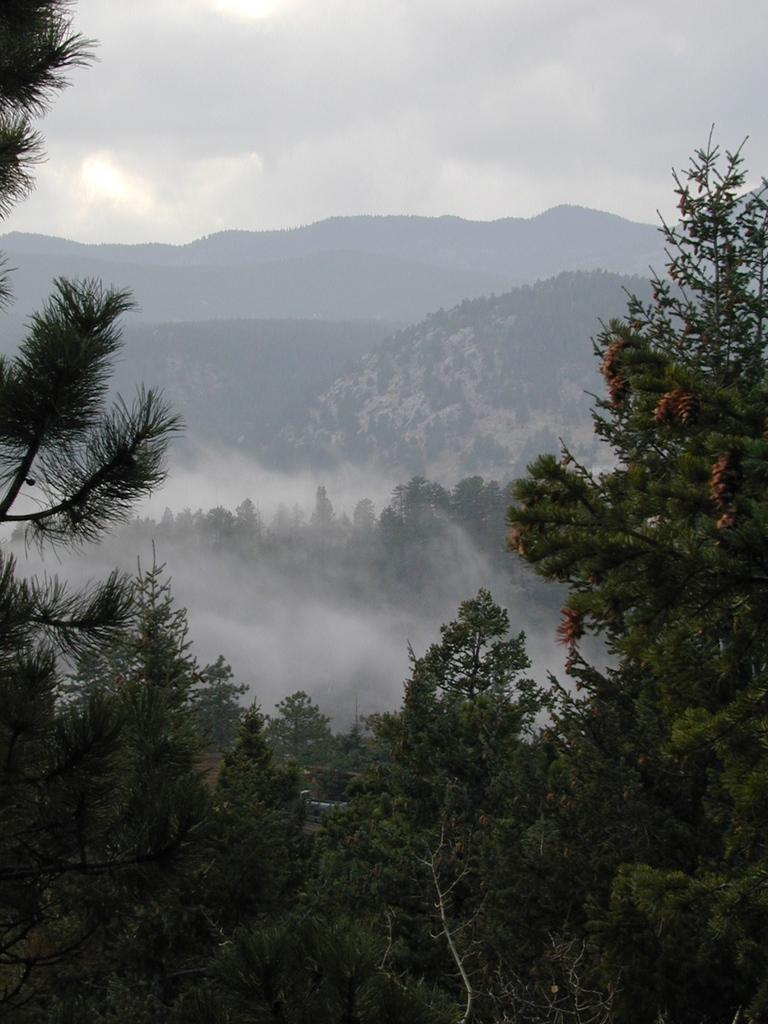What type of natural formation can be seen in the image? There are mountains in the image. What type of vegetation is present in the image? There are trees with leaves and branches in the image. What atmospheric condition is visible in the image? There is fog in the image. What part of the natural environment is visible in the image? The sky is visible in the image. What else can be seen in the sky? Clouds are present in the sky. What type of cheese is being used to create the arm in the image? There is no cheese or arm present in the image. What type of land can be seen in the image? The image does not specifically show land, but it does show mountains and trees, which are located on land. 